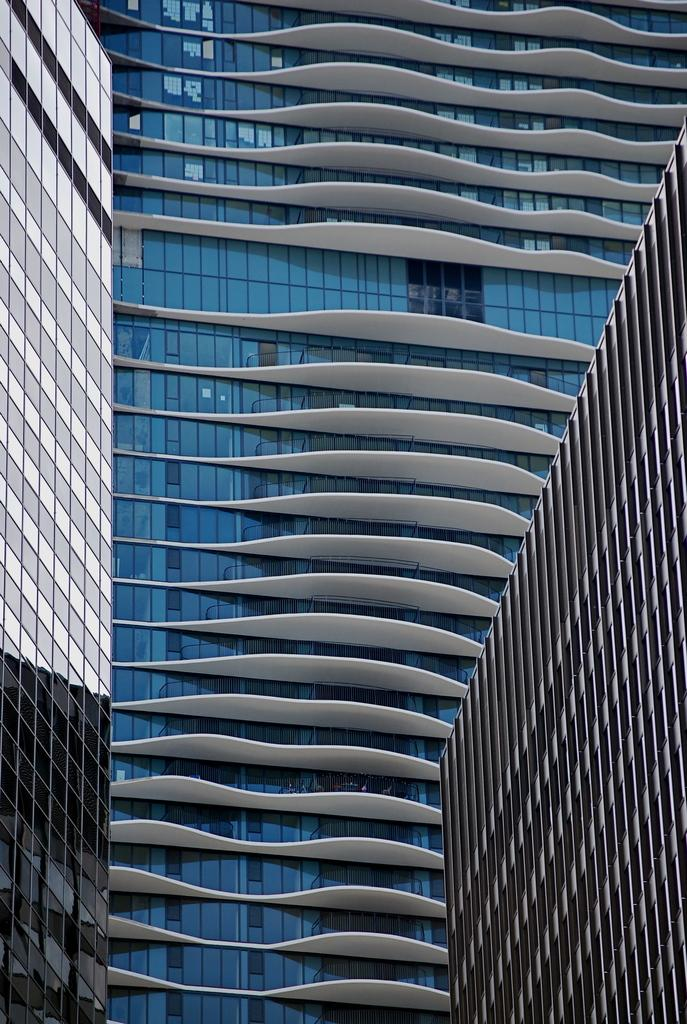How many buildings can be seen in the image? There are three buildings in the image. What type of operation is being performed on the buildings in the image? There is no operation being performed on the buildings in the image; the fact only states that there are three buildings present. 